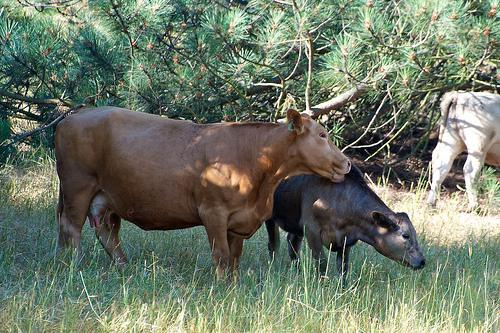Question: when was this pic taken?
Choices:
A. During the daytime.
B. Nightime.
C. Victorian era.
D. At sunset.
Answer with the letter. Answer: A Question: what color is the animal in the background?
Choices:
A. White.
B. Red.
C. Brown.
D. Gray.
Answer with the letter. Answer: D Question: what sex are the animals?
Choices:
A. Female.
B. Male.
C. Unknown.
D. Male and female.
Answer with the letter. Answer: A Question: how many pairs of legs are visible?
Choices:
A. 5.
B. 1.
C. 2.
D. 3.
Answer with the letter. Answer: A Question: why are the animals standing in the field?
Choices:
A. Grazing.
B. Sleeping.
C. Tired.
D. Lost.
Answer with the letter. Answer: A Question: where was this pic taken?
Choices:
A. Outside near animals.
B. Outside near car.
C. Inside of barn.
D. Outside under tent.
Answer with the letter. Answer: A 